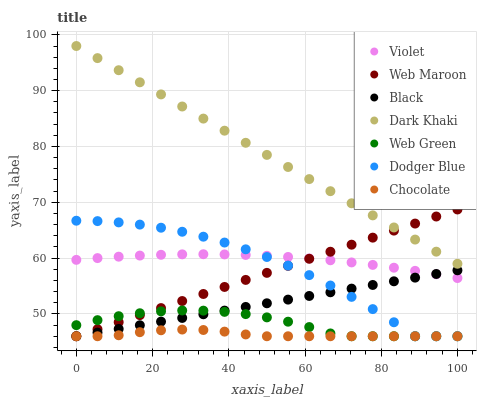Does Chocolate have the minimum area under the curve?
Answer yes or no. Yes. Does Dark Khaki have the maximum area under the curve?
Answer yes or no. Yes. Does Web Green have the minimum area under the curve?
Answer yes or no. No. Does Web Green have the maximum area under the curve?
Answer yes or no. No. Is Web Maroon the smoothest?
Answer yes or no. Yes. Is Dodger Blue the roughest?
Answer yes or no. Yes. Is Web Green the smoothest?
Answer yes or no. No. Is Web Green the roughest?
Answer yes or no. No. Does Web Maroon have the lowest value?
Answer yes or no. Yes. Does Dark Khaki have the lowest value?
Answer yes or no. No. Does Dark Khaki have the highest value?
Answer yes or no. Yes. Does Web Green have the highest value?
Answer yes or no. No. Is Web Green less than Dark Khaki?
Answer yes or no. Yes. Is Violet greater than Web Green?
Answer yes or no. Yes. Does Dodger Blue intersect Chocolate?
Answer yes or no. Yes. Is Dodger Blue less than Chocolate?
Answer yes or no. No. Is Dodger Blue greater than Chocolate?
Answer yes or no. No. Does Web Green intersect Dark Khaki?
Answer yes or no. No. 